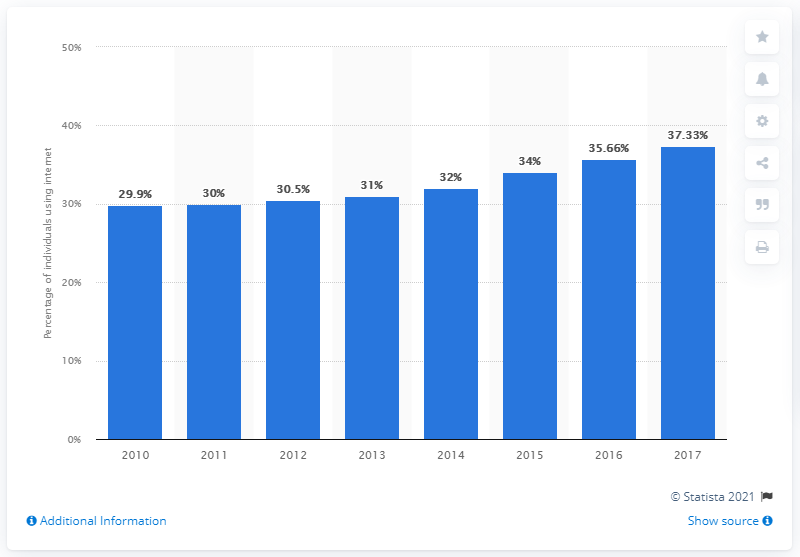Mention a couple of crucial points in this snapshot. In 2017, 37.33% of Guyana's population accessed the internet. 